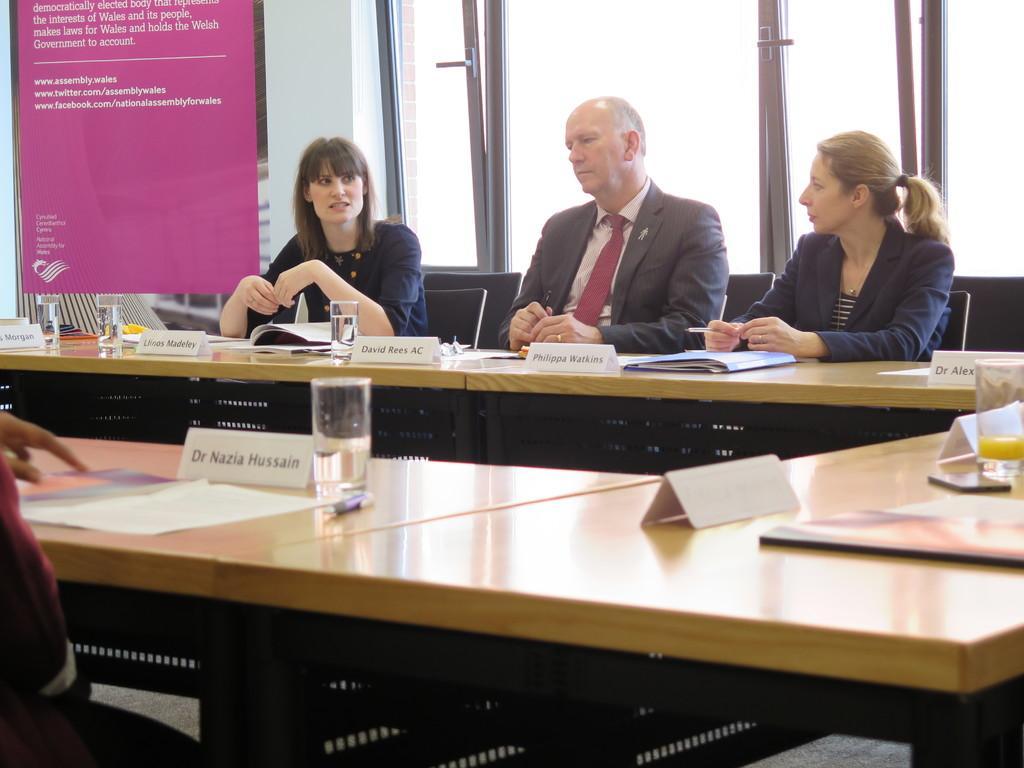Could you give a brief overview of what you see in this image? In this image there are three persons who are sitting on a chair in front of them there is one table and on the table there are some books glasses and name plates are there and in the middle of the image there is one glass window and on the left side of the image there is one poster. 